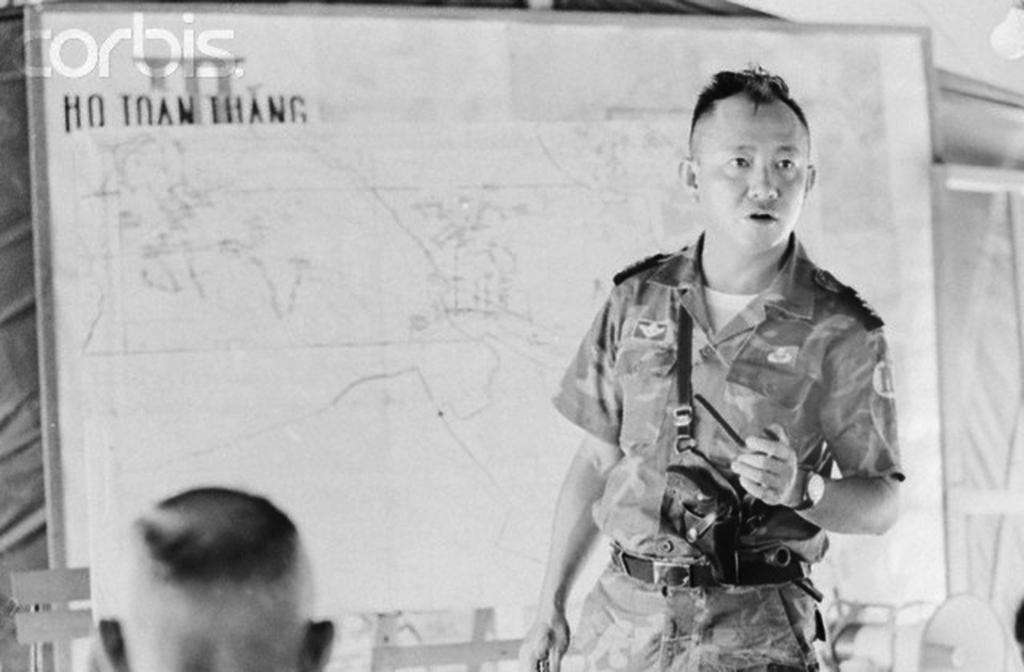What is the position of the man in the image? The man is standing on the right side of the image. What is the man wearing in the image? The man is wearing a uniform in the image. What can be seen in the background of the image? There is a board in the background of the image. Who else is present in the image besides the man? There is a person at the bottom of the image. What can be seen providing illumination in the image? There is a light visible in the image. What type of mitten is the man wearing in the image? The man is not wearing a mitten in the image; he is wearing a uniform. What route is the person at the bottom of the image taking? There is no information about a route in the image; it only shows a person at the bottom. 